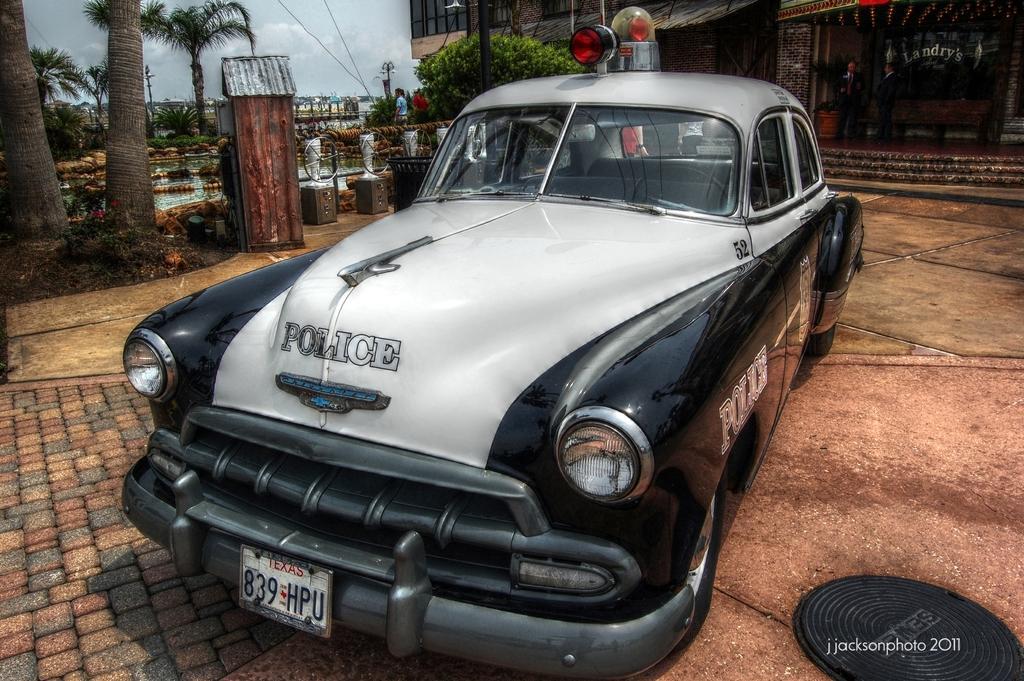In one or two sentences, can you explain what this image depicts? In the foreground of this image, there is a police car on the ground in front of a building. In the background, there are trees, water, a person, and the sky. 